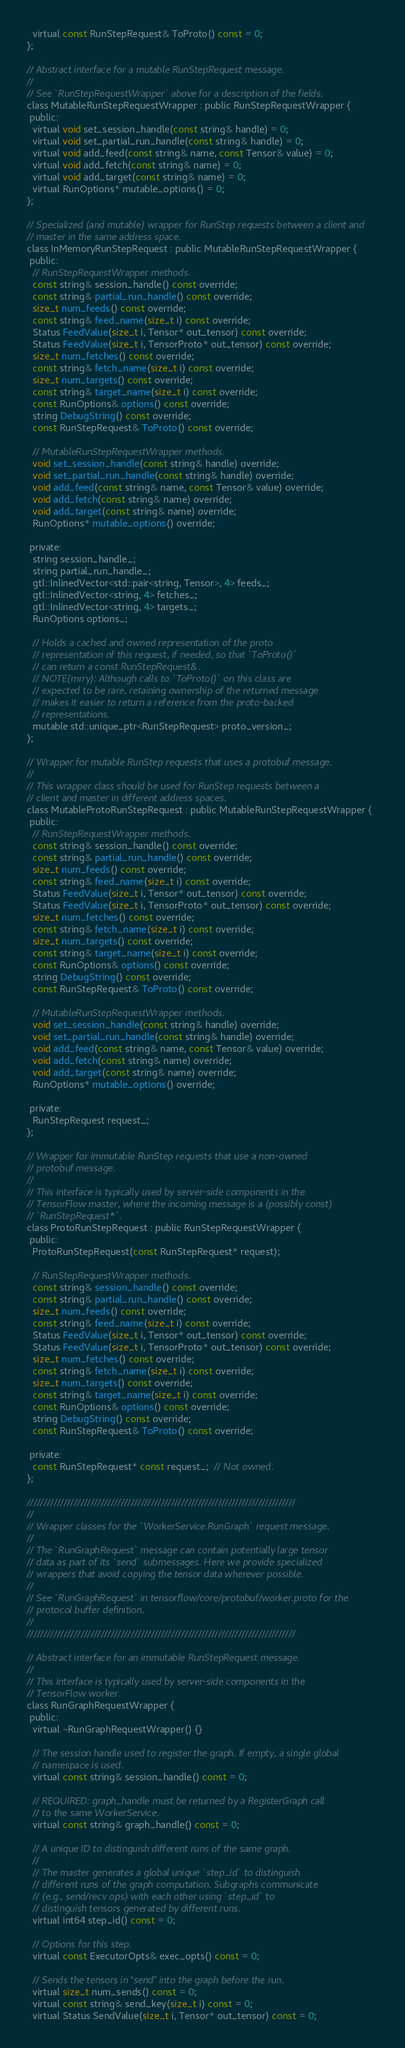<code> <loc_0><loc_0><loc_500><loc_500><_C_>  virtual const RunStepRequest& ToProto() const = 0;
};

// Abstract interface for a mutable RunStepRequest message.
//
// See `RunStepRequestWrapper` above for a description of the fields.
class MutableRunStepRequestWrapper : public RunStepRequestWrapper {
 public:
  virtual void set_session_handle(const string& handle) = 0;
  virtual void set_partial_run_handle(const string& handle) = 0;
  virtual void add_feed(const string& name, const Tensor& value) = 0;
  virtual void add_fetch(const string& name) = 0;
  virtual void add_target(const string& name) = 0;
  virtual RunOptions* mutable_options() = 0;
};

// Specialized (and mutable) wrapper for RunStep requests between a client and
// master in the same address space.
class InMemoryRunStepRequest : public MutableRunStepRequestWrapper {
 public:
  // RunStepRequestWrapper methods.
  const string& session_handle() const override;
  const string& partial_run_handle() const override;
  size_t num_feeds() const override;
  const string& feed_name(size_t i) const override;
  Status FeedValue(size_t i, Tensor* out_tensor) const override;
  Status FeedValue(size_t i, TensorProto* out_tensor) const override;
  size_t num_fetches() const override;
  const string& fetch_name(size_t i) const override;
  size_t num_targets() const override;
  const string& target_name(size_t i) const override;
  const RunOptions& options() const override;
  string DebugString() const override;
  const RunStepRequest& ToProto() const override;

  // MutableRunStepRequestWrapper methods.
  void set_session_handle(const string& handle) override;
  void set_partial_run_handle(const string& handle) override;
  void add_feed(const string& name, const Tensor& value) override;
  void add_fetch(const string& name) override;
  void add_target(const string& name) override;
  RunOptions* mutable_options() override;

 private:
  string session_handle_;
  string partial_run_handle_;
  gtl::InlinedVector<std::pair<string, Tensor>, 4> feeds_;
  gtl::InlinedVector<string, 4> fetches_;
  gtl::InlinedVector<string, 4> targets_;
  RunOptions options_;

  // Holds a cached and owned representation of the proto
  // representation of this request, if needed, so that `ToProto()`
  // can return a const RunStepRequest&.
  // NOTE(mrry): Although calls to `ToProto()` on this class are
  // expected to be rare, retaining ownership of the returned message
  // makes it easier to return a reference from the proto-backed
  // representations.
  mutable std::unique_ptr<RunStepRequest> proto_version_;
};

// Wrapper for mutable RunStep requests that uses a protobuf message.
//
// This wrapper class should be used for RunStep requests between a
// client and master in different address spaces.
class MutableProtoRunStepRequest : public MutableRunStepRequestWrapper {
 public:
  // RunStepRequestWrapper methods.
  const string& session_handle() const override;
  const string& partial_run_handle() const override;
  size_t num_feeds() const override;
  const string& feed_name(size_t i) const override;
  Status FeedValue(size_t i, Tensor* out_tensor) const override;
  Status FeedValue(size_t i, TensorProto* out_tensor) const override;
  size_t num_fetches() const override;
  const string& fetch_name(size_t i) const override;
  size_t num_targets() const override;
  const string& target_name(size_t i) const override;
  const RunOptions& options() const override;
  string DebugString() const override;
  const RunStepRequest& ToProto() const override;

  // MutableRunStepRequestWrapper methods.
  void set_session_handle(const string& handle) override;
  void set_partial_run_handle(const string& handle) override;
  void add_feed(const string& name, const Tensor& value) override;
  void add_fetch(const string& name) override;
  void add_target(const string& name) override;
  RunOptions* mutable_options() override;

 private:
  RunStepRequest request_;
};

// Wrapper for immutable RunStep requests that use a non-owned
// protobuf message.
//
// This interface is typically used by server-side components in the
// TensorFlow master, where the incoming message is a (possibly const)
// `RunStepRequest*`.
class ProtoRunStepRequest : public RunStepRequestWrapper {
 public:
  ProtoRunStepRequest(const RunStepRequest* request);

  // RunStepRequestWrapper methods.
  const string& session_handle() const override;
  const string& partial_run_handle() const override;
  size_t num_feeds() const override;
  const string& feed_name(size_t i) const override;
  Status FeedValue(size_t i, Tensor* out_tensor) const override;
  Status FeedValue(size_t i, TensorProto* out_tensor) const override;
  size_t num_fetches() const override;
  const string& fetch_name(size_t i) const override;
  size_t num_targets() const override;
  const string& target_name(size_t i) const override;
  const RunOptions& options() const override;
  string DebugString() const override;
  const RunStepRequest& ToProto() const override;

 private:
  const RunStepRequest* const request_;  // Not owned.
};

////////////////////////////////////////////////////////////////////////////////
//
// Wrapper classes for the `WorkerService.RunGraph` request message.
//
// The `RunGraphRequest` message can contain potentially large tensor
// data as part of its `send` submessages. Here we provide specialized
// wrappers that avoid copying the tensor data wherever possible.
//
// See `RunGraphRequest` in tensorflow/core/protobuf/worker.proto for the
// protocol buffer definition.
//
////////////////////////////////////////////////////////////////////////////////

// Abstract interface for an immutable RunStepRequest message.
//
// This interface is typically used by server-side components in the
// TensorFlow worker.
class RunGraphRequestWrapper {
 public:
  virtual ~RunGraphRequestWrapper() {}

  // The session handle used to register the graph. If empty, a single global
  // namespace is used.
  virtual const string& session_handle() const = 0;

  // REQUIRED: graph_handle must be returned by a RegisterGraph call
  // to the same WorkerService.
  virtual const string& graph_handle() const = 0;

  // A unique ID to distinguish different runs of the same graph.
  //
  // The master generates a global unique `step_id` to distinguish
  // different runs of the graph computation. Subgraphs communicate
  // (e.g., send/recv ops) with each other using `step_id` to
  // distinguish tensors generated by different runs.
  virtual int64 step_id() const = 0;

  // Options for this step.
  virtual const ExecutorOpts& exec_opts() const = 0;

  // Sends the tensors in "send" into the graph before the run.
  virtual size_t num_sends() const = 0;
  virtual const string& send_key(size_t i) const = 0;
  virtual Status SendValue(size_t i, Tensor* out_tensor) const = 0;
</code> 